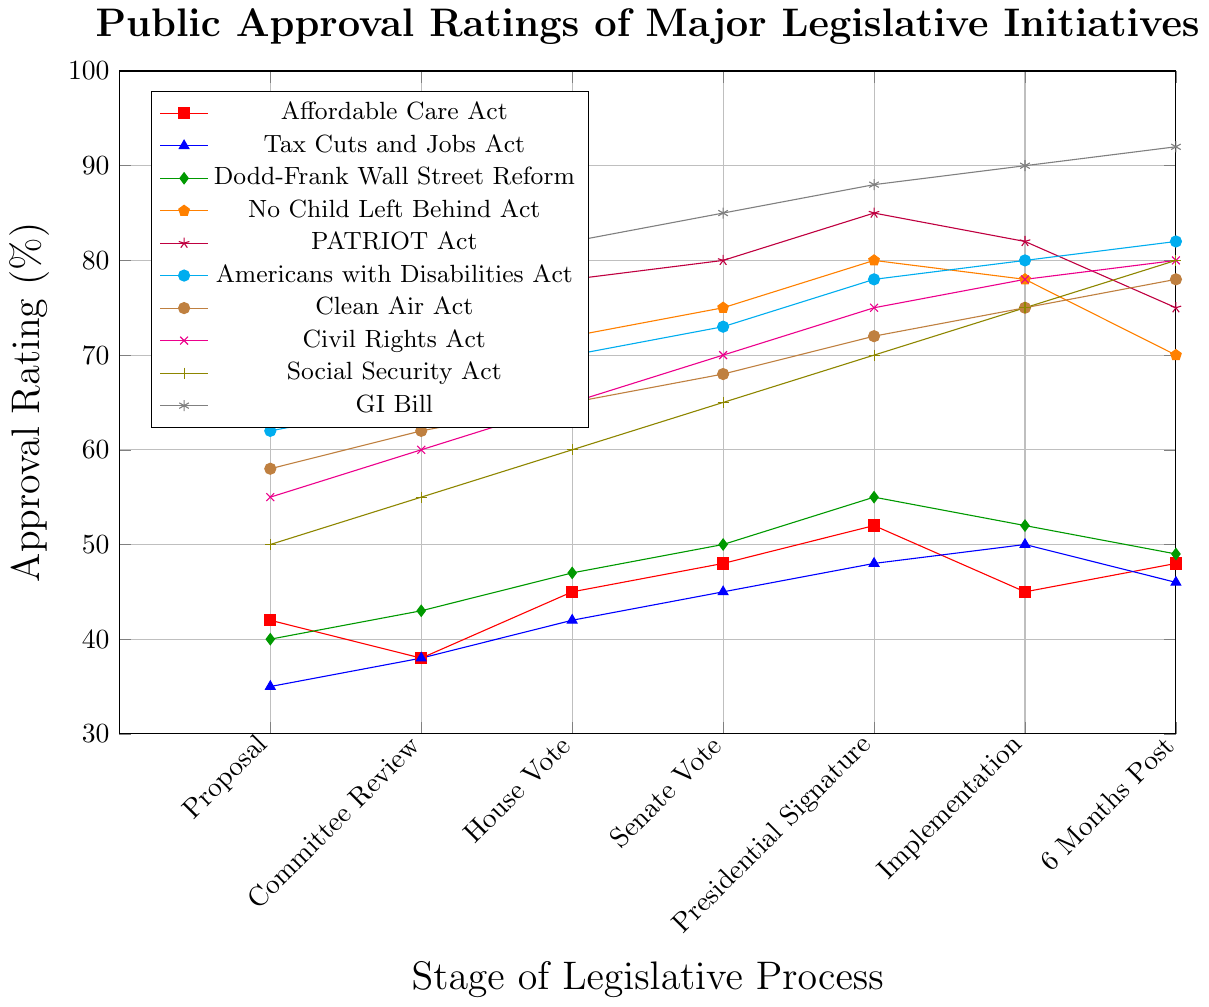What is the approximate average approval rating for the Affordable Care Act from Proposal to 6 Months Post-Implementation? To find the average approval rating for the Affordable Care Act, sum the approval percentages at each stage (42, 38, 45, 48, 52, 45, 48) and then divide by the number of stages (7). The calculation is (42 + 38 + 45 + 48 + 52 + 45 + 48) / 7 = 318 / 7 = 45.43.
Answer: 45.43 Which legislative initiative had the highest approval rating 6 months after implementation? Refer to the data points 6 months post-implementation: Affordable Care Act (48), Tax Cuts and Jobs Act (46), Dodd-Frank Wall Street Reform (49), No Child Left Behind Act (70), PATRIOT Act (75), Americans with Disabilities Act (82), Clean Air Act (78), Civil Rights Act (80), Social Security Act (80), GI Bill (92). The highest value is 92, which corresponds to the GI Bill.
Answer: GI Bill Compare the initial (Proposal) approval ratings for the No Child Left Behind Act and the Americans with Disabilities Act. Which one had higher initial support? Check the Proposal stage approval ratings for the two initiatives: No Child Left Behind Act (65) and Americans with Disabilities Act (62). Since 65 > 62, the No Child Left Behind Act had higher initial support.
Answer: No Child Left Behind Act What is the difference in approval rating between the Proposal and 6 Months Post-Implementation stages for the Clean Air Act? Determine the approval ratings for the Proposal (58) and 6 Months Post-Implementation (78) stages of the Clean Air Act. The difference is 78 - 58 = 20.
Answer: 20 Does the PATRIOT Act experience a steady increase in approval ratings from Proposal to Implementation? Analyze the approval ratings for the PATRIOT Act at each stage: Proposal (70), Committee Review (73), House Vote (78), Senate Vote (80), Presidential Signature (85), Implementation (82). Notice the ratings increase consistently from Proposal to Presidential Signature, but there is a drop from Presidential Signature to Implementation (85 -> 82). Hence, the increase is not steady.
Answer: No 